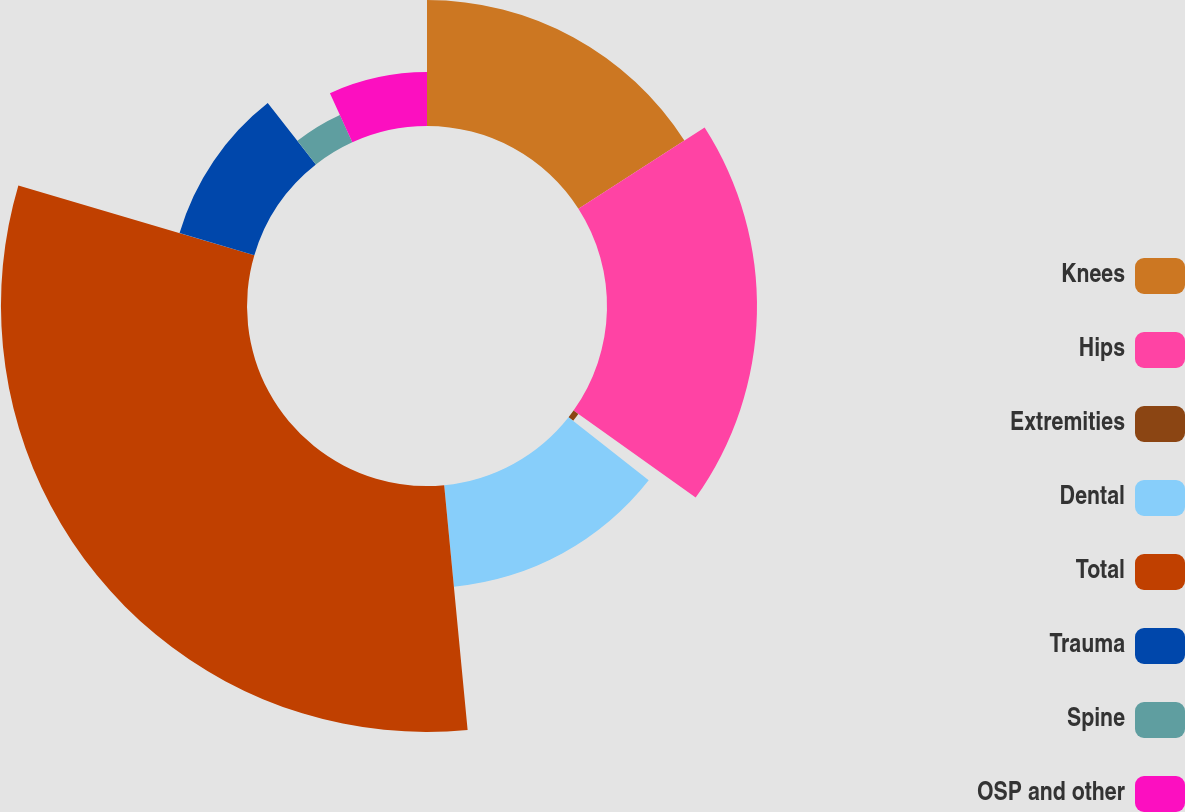<chart> <loc_0><loc_0><loc_500><loc_500><pie_chart><fcel>Knees<fcel>Hips<fcel>Extremities<fcel>Dental<fcel>Total<fcel>Trauma<fcel>Spine<fcel>OSP and other<nl><fcel>15.91%<fcel>18.95%<fcel>0.74%<fcel>12.88%<fcel>31.08%<fcel>9.85%<fcel>3.78%<fcel>6.81%<nl></chart> 